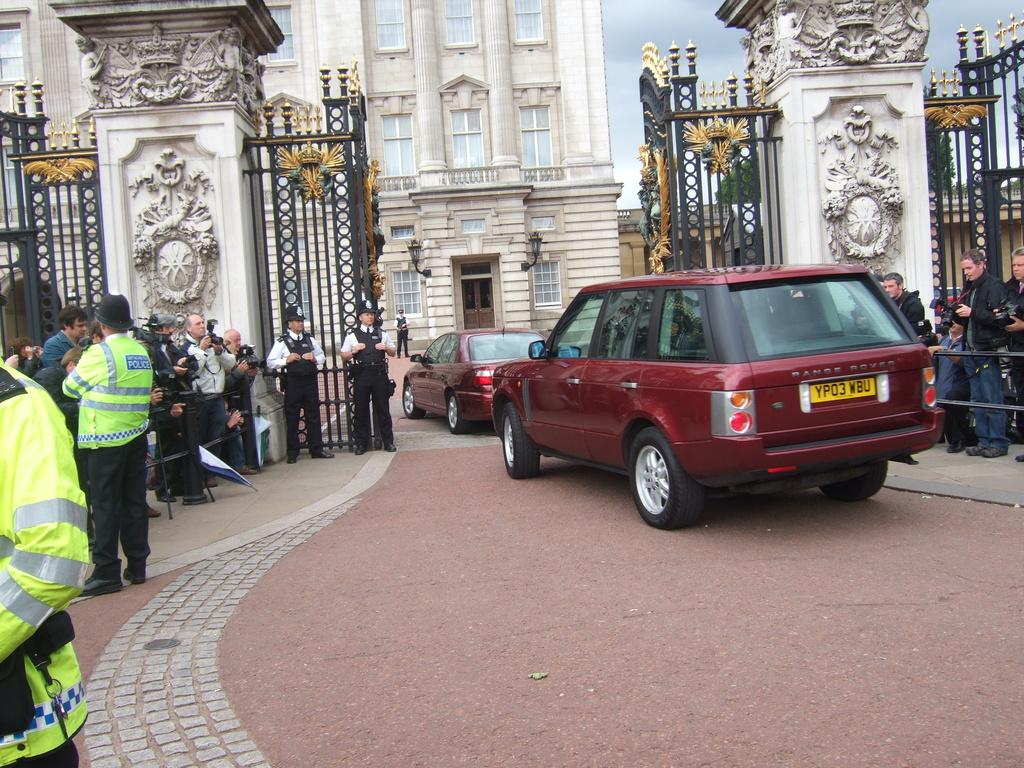What types of objects are present in the image? There are vehicles in the image. What else can be seen in the image besides the vehicles? There are people on the ground in the image. What is visible in the background of the image? There is a building and the sky in the background of the image. How many chances does the hammer have to hit the building in the image? There is no hammer present in the image, so it cannot be determined how many chances it has to hit the building. 